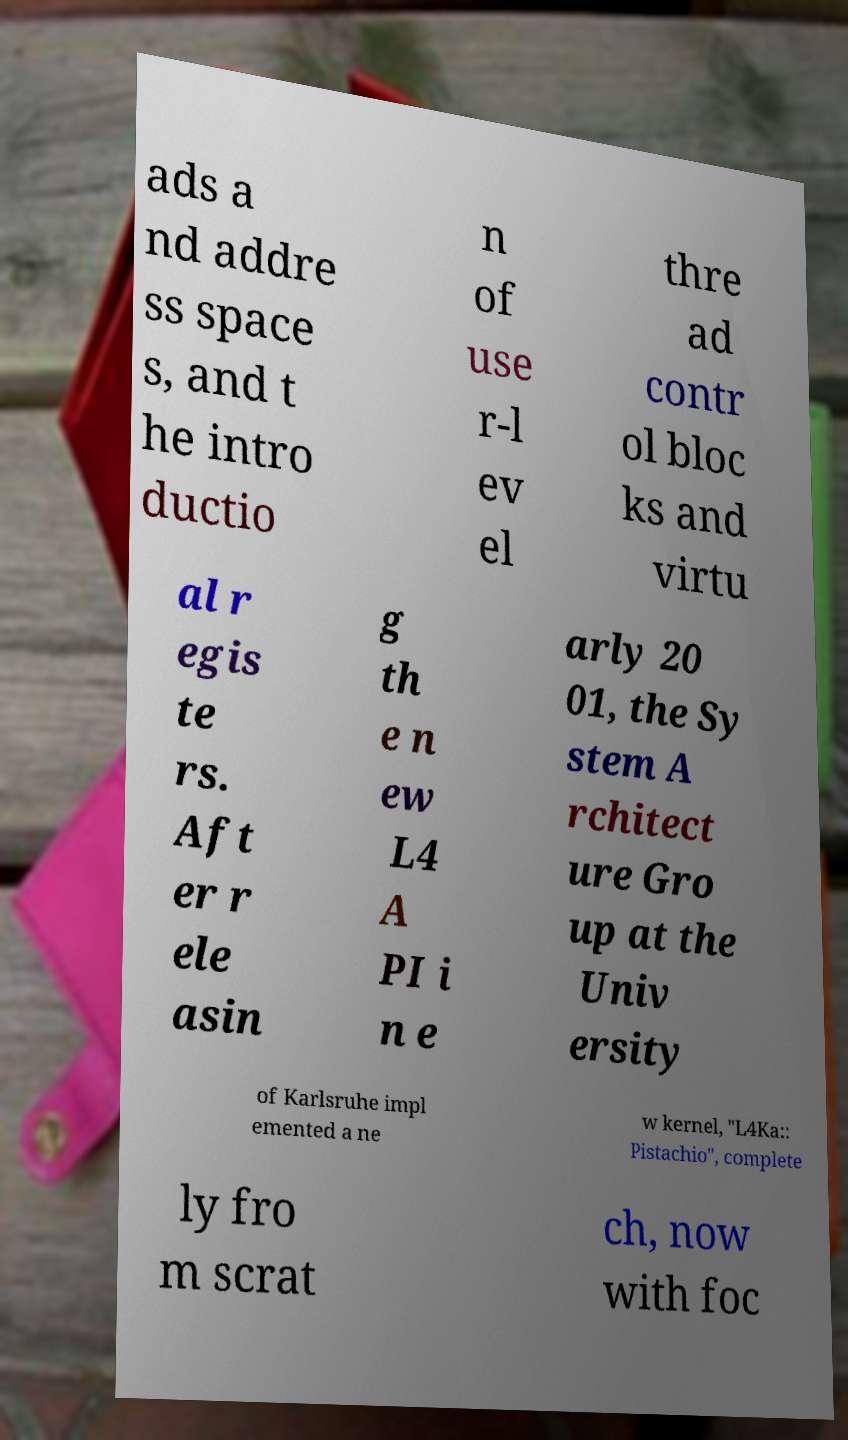Can you read and provide the text displayed in the image?This photo seems to have some interesting text. Can you extract and type it out for me? ads a nd addre ss space s, and t he intro ductio n of use r-l ev el thre ad contr ol bloc ks and virtu al r egis te rs. Aft er r ele asin g th e n ew L4 A PI i n e arly 20 01, the Sy stem A rchitect ure Gro up at the Univ ersity of Karlsruhe impl emented a ne w kernel, "L4Ka:: Pistachio", complete ly fro m scrat ch, now with foc 